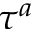<formula> <loc_0><loc_0><loc_500><loc_500>\tau ^ { a }</formula> 